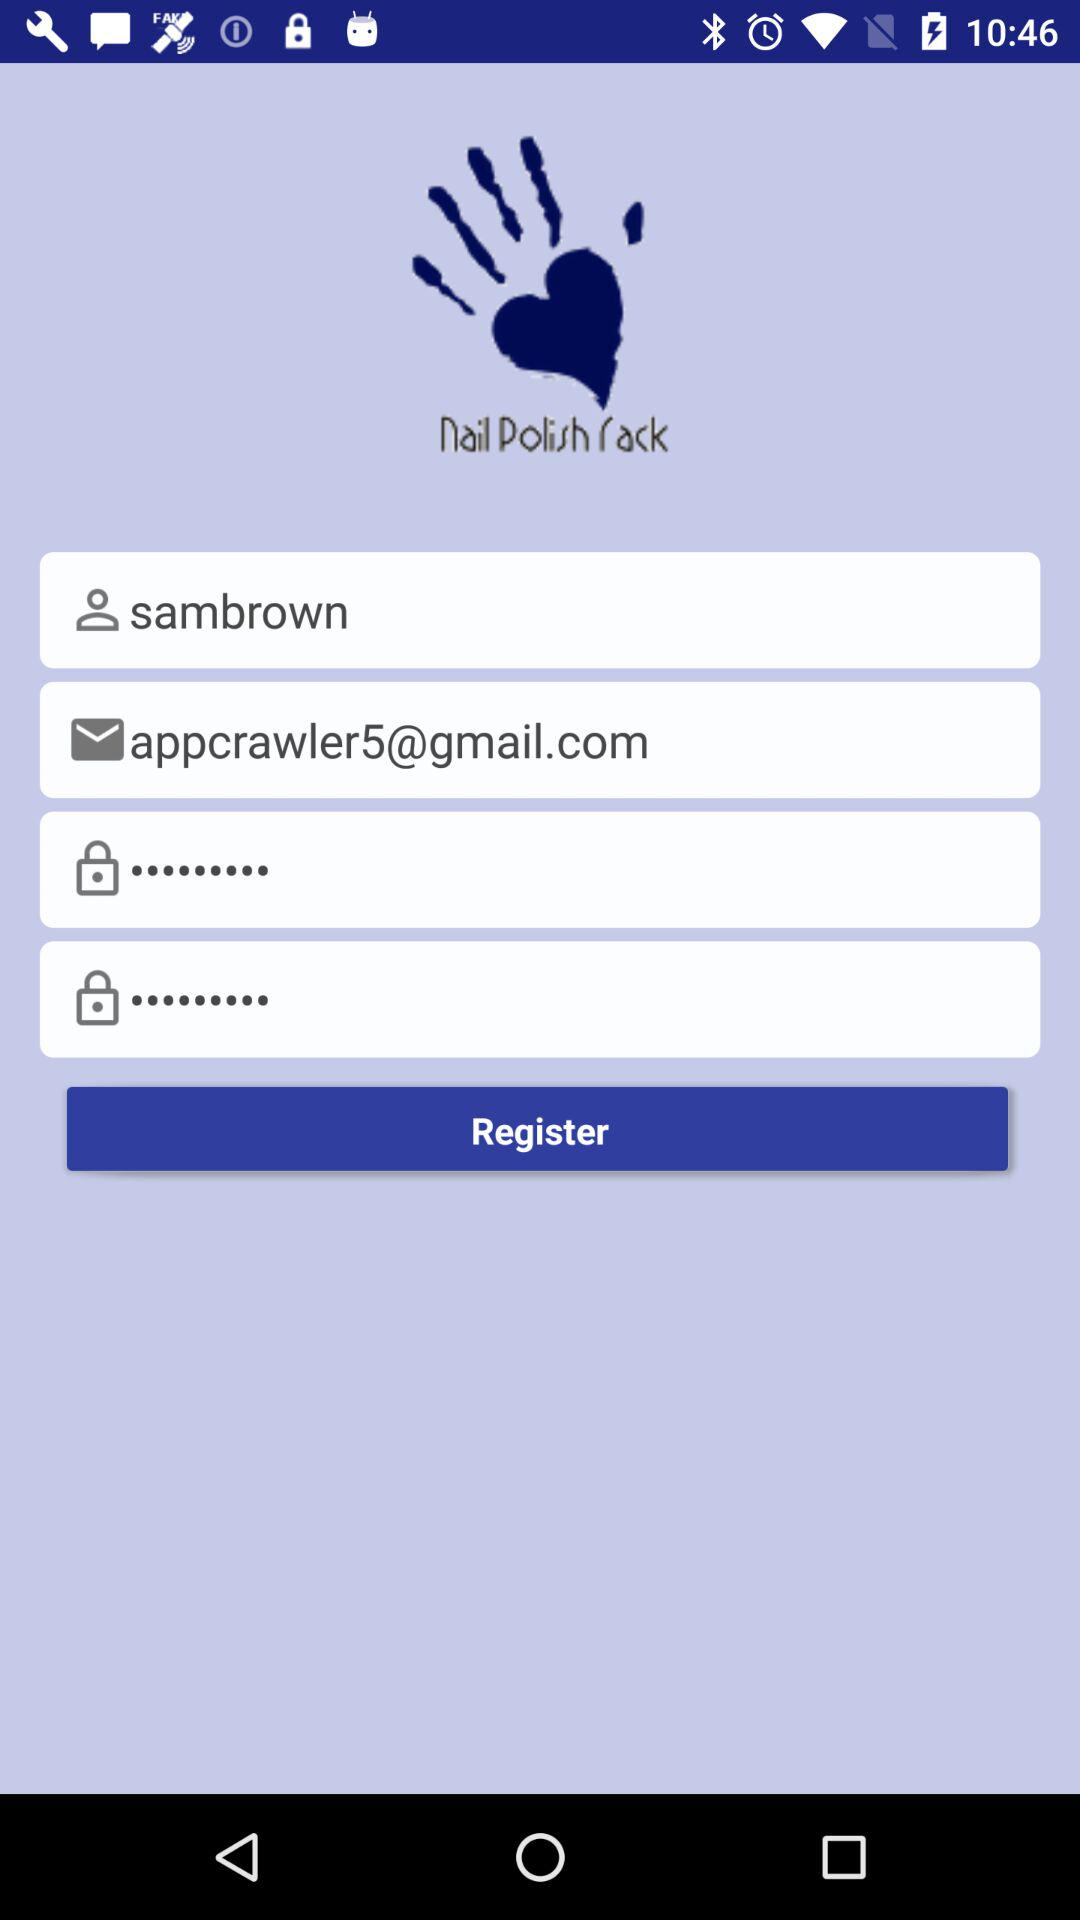What is the name of the user? The name of the user is Sambrown. 